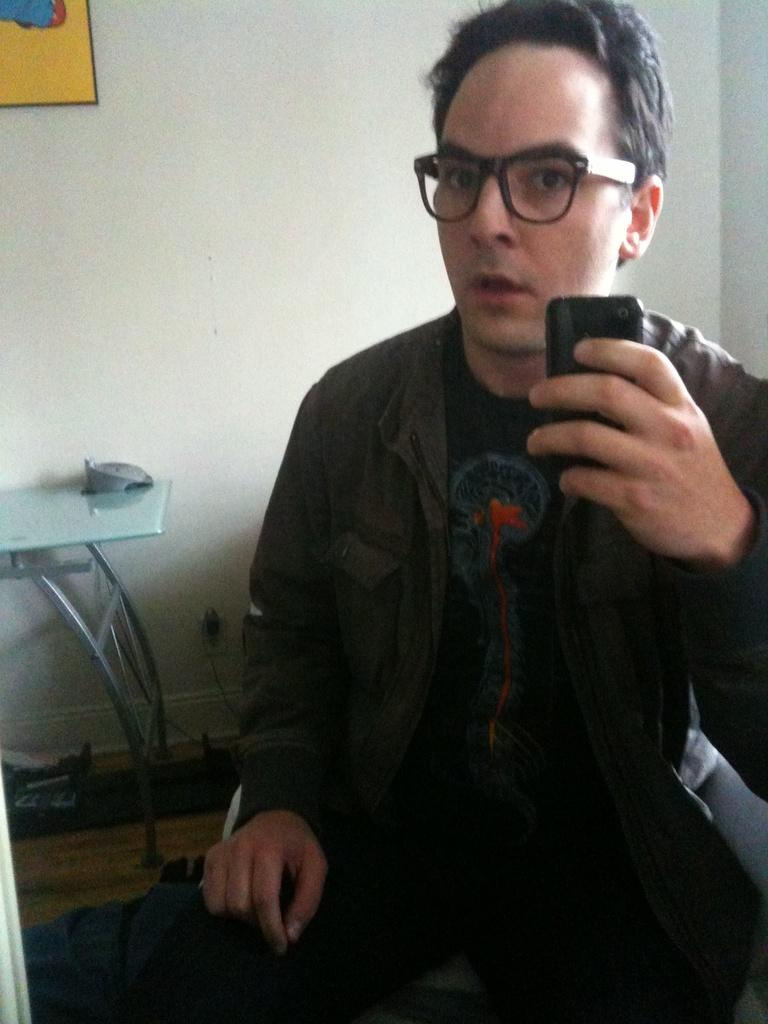Who is present in the image? There is a man in the image. What is the man holding in the image? The man is holding a mobile in the image. What can be seen in the background of the image? There is a wall in the background of the image. What is on the wall in the image? There is a frame on the wall in the image. What is located on the left side of the image? There is a table on the left side of the image. What type of leaf is being used as a drum in the image? There is no leaf or drum present in the image. What scene is depicted in the frame on the wall? The image does not provide information about the scene depicted in the frame on the wall. 